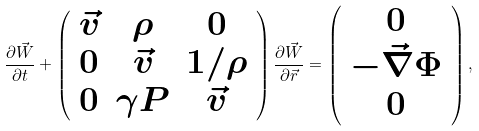<formula> <loc_0><loc_0><loc_500><loc_500>\frac { \partial \vec { W } } { \partial t } + \left ( \begin{array} { c c c } \vec { v } & \rho & 0 \\ 0 & \vec { v } & 1 / \rho \\ 0 & \gamma P & \vec { v } \\ \end{array} \right ) \frac { \partial \vec { W } } { \partial \vec { r } } = \left ( \begin{array} { c } 0 \\ - \vec { \nabla } \Phi \\ 0 \end{array} \right ) ,</formula> 